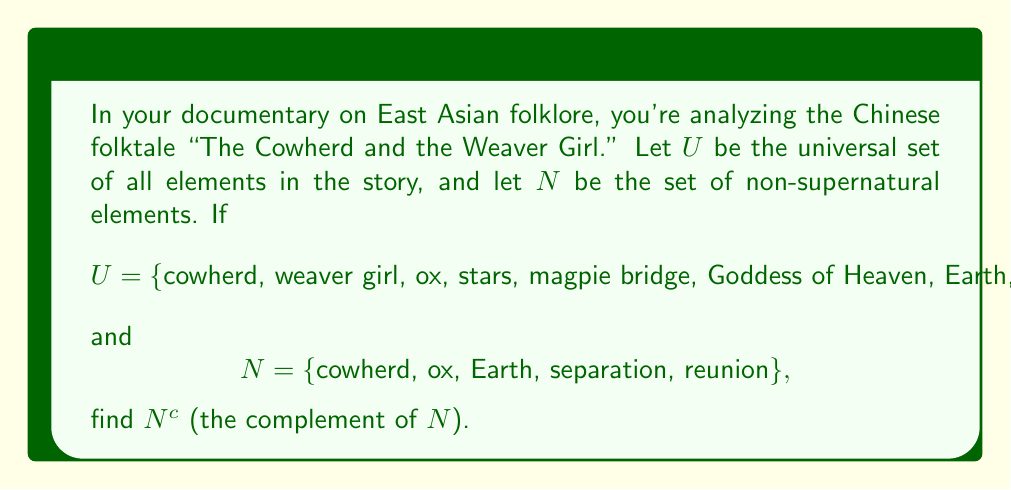Give your solution to this math problem. To find the complement of set $N$, we need to identify all elements in the universal set $U$ that are not in set $N$. This can be done through the following steps:

1. Identify the universal set $U$:
   $U = \{cowherd, weaver girl, ox, stars, magpie bridge, Goddess of Heaven, Earth, separation, reunion\}$

2. Identify set $N$:
   $N = \{cowherd, ox, Earth, separation, reunion\}$

3. The complement of $N$, denoted as $N^c$, is defined as:
   $N^c = \{x \in U : x \notin N\}$

4. Compare each element in $U$ with the elements in $N$:
   - "cowherd" is in $N$, so it's not in $N^c$
   - "weaver girl" is not in $N$, so it's in $N^c$
   - "ox" is in $N$, so it's not in $N^c$
   - "stars" is not in $N$, so it's in $N^c$
   - "magpie bridge" is not in $N$, so it's in $N^c$
   - "Goddess of Heaven" is not in $N$, so it's in $N^c$
   - "Earth" is in $N$, so it's not in $N^c$
   - "separation" is in $N$, so it's not in $N^c$
   - "reunion" is in $N$, so it's not in $N^c$

5. Collect all elements that are in $U$ but not in $N$ to form $N^c$
Answer: $N^c = \{weaver girl, stars, magpie bridge, Goddess of Heaven\}$ 